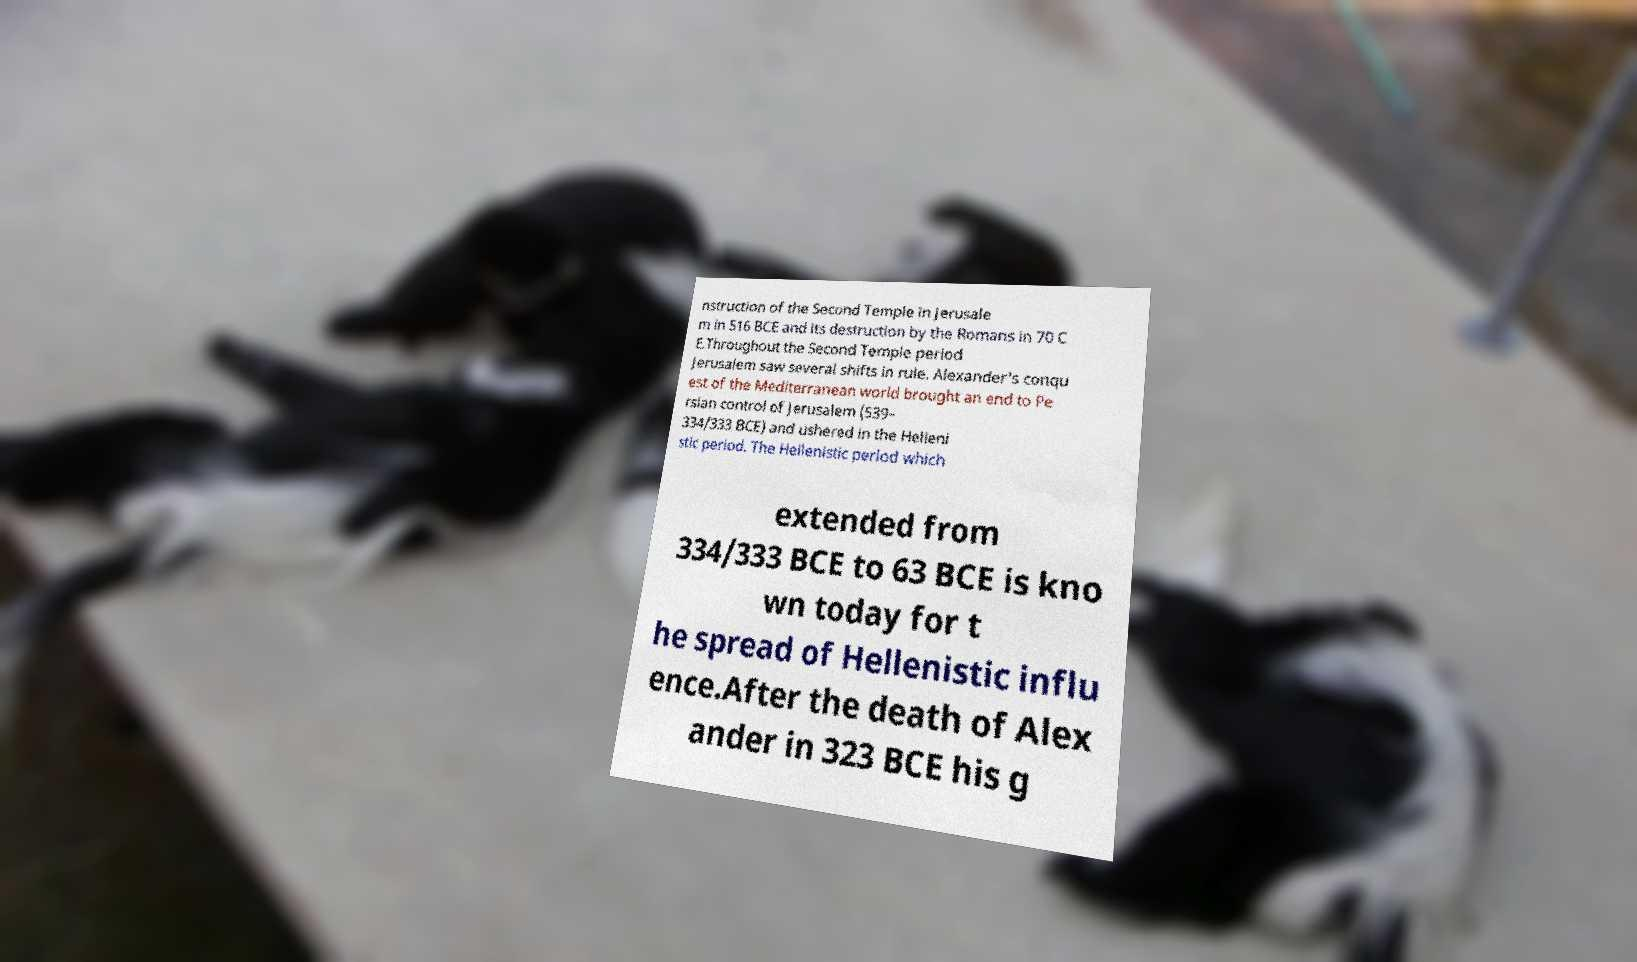Can you read and provide the text displayed in the image?This photo seems to have some interesting text. Can you extract and type it out for me? nstruction of the Second Temple in Jerusale m in 516 BCE and its destruction by the Romans in 70 C E.Throughout the Second Temple period Jerusalem saw several shifts in rule. Alexander's conqu est of the Mediterranean world brought an end to Pe rsian control of Jerusalem (539– 334/333 BCE) and ushered in the Helleni stic period. The Hellenistic period which extended from 334/333 BCE to 63 BCE is kno wn today for t he spread of Hellenistic influ ence.After the death of Alex ander in 323 BCE his g 